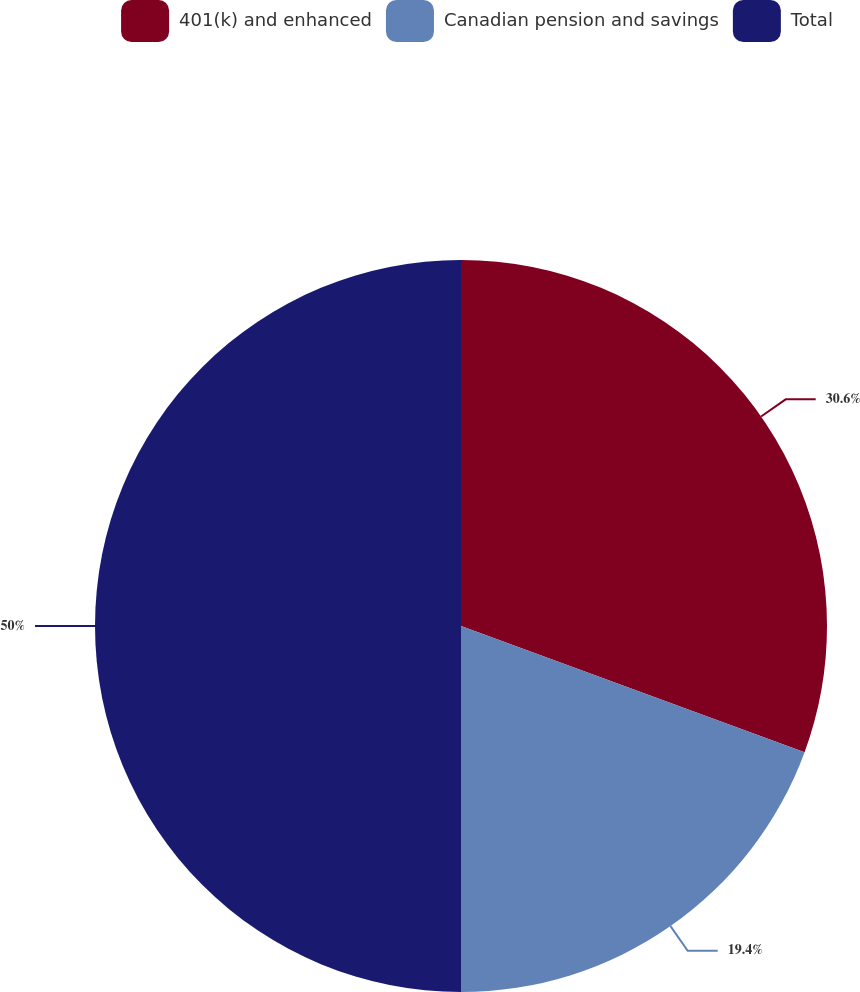Convert chart to OTSL. <chart><loc_0><loc_0><loc_500><loc_500><pie_chart><fcel>401(k) and enhanced<fcel>Canadian pension and savings<fcel>Total<nl><fcel>30.6%<fcel>19.4%<fcel>50.0%<nl></chart> 